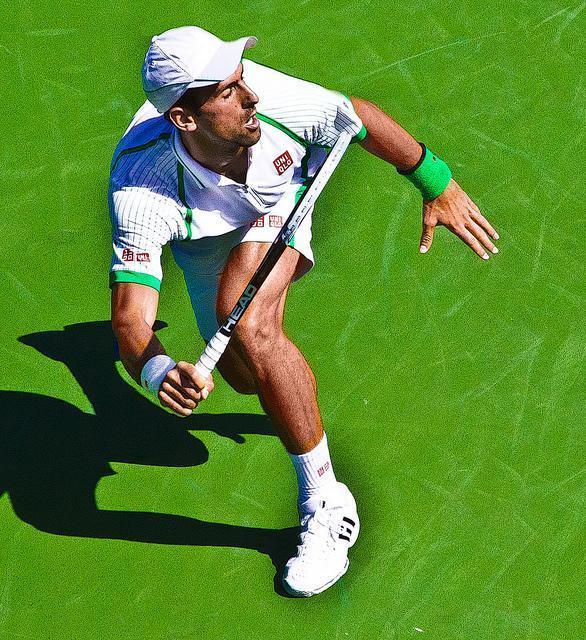How many zebras are in the picture?
Give a very brief answer. 0. 